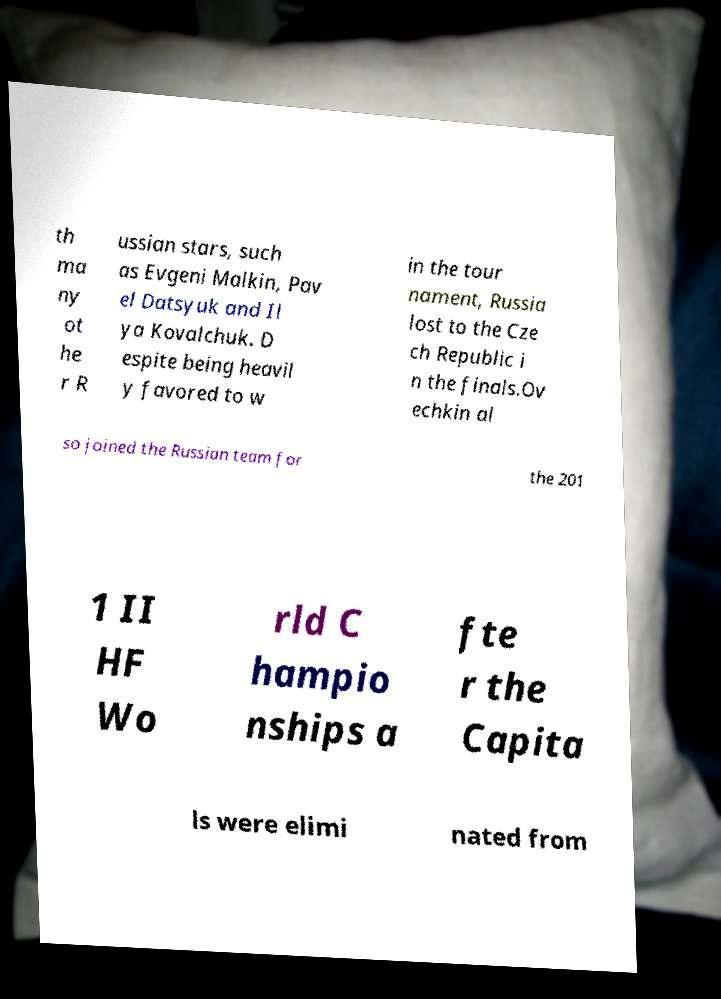I need the written content from this picture converted into text. Can you do that? th ma ny ot he r R ussian stars, such as Evgeni Malkin, Pav el Datsyuk and Il ya Kovalchuk. D espite being heavil y favored to w in the tour nament, Russia lost to the Cze ch Republic i n the finals.Ov echkin al so joined the Russian team for the 201 1 II HF Wo rld C hampio nships a fte r the Capita ls were elimi nated from 